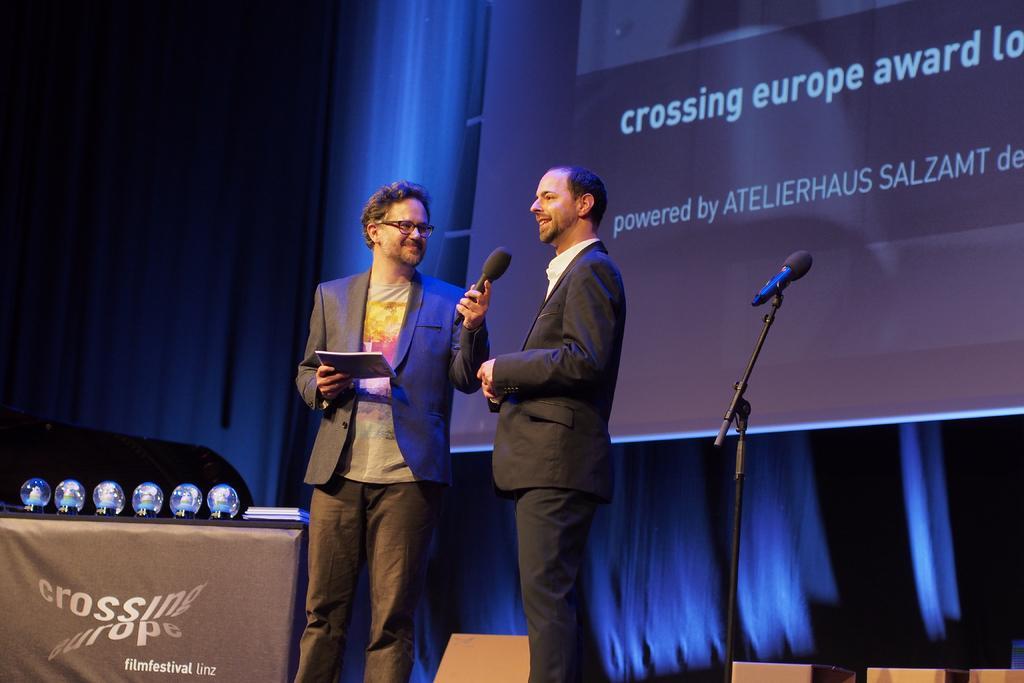Could you give a brief overview of what you see in this image? In this image there are two persons standing , a person holding a book and a mike, and there are plasma balls and books on the table, and in the background there is a mike with a mike stand , curtains and a screen. 